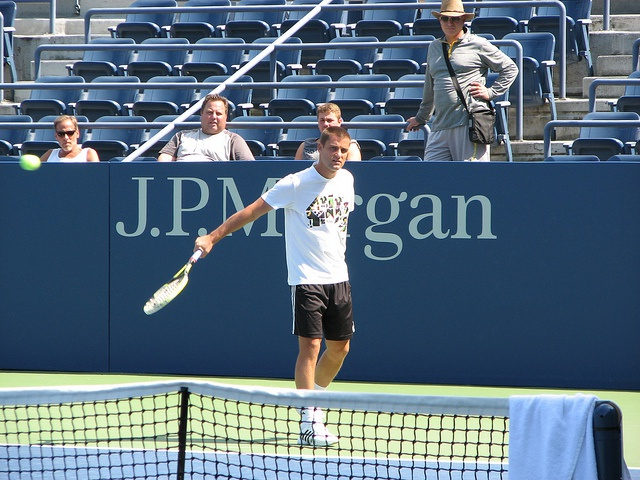Describe the objects in this image and their specific colors. I can see people in darkblue, white, black, lightblue, and gray tones, people in darkblue, gray, white, and black tones, people in darkblue, white, darkgray, and gray tones, handbag in darkblue, black, gray, darkgray, and blue tones, and people in darkblue, white, tan, gray, and black tones in this image. 